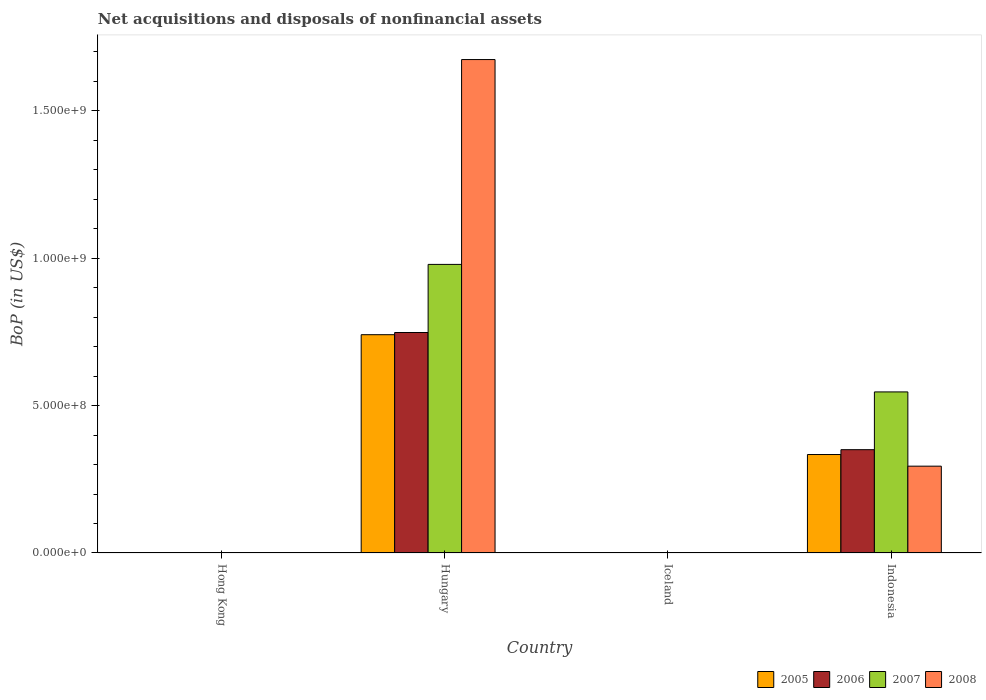Are the number of bars on each tick of the X-axis equal?
Offer a terse response. No. What is the label of the 1st group of bars from the left?
Your answer should be very brief. Hong Kong. What is the Balance of Payments in 2008 in Hungary?
Your answer should be very brief. 1.67e+09. Across all countries, what is the maximum Balance of Payments in 2007?
Offer a terse response. 9.79e+08. In which country was the Balance of Payments in 2006 maximum?
Your answer should be compact. Hungary. What is the total Balance of Payments in 2005 in the graph?
Make the answer very short. 1.07e+09. What is the difference between the Balance of Payments in 2007 in Hungary and that in Indonesia?
Your answer should be compact. 4.32e+08. What is the difference between the Balance of Payments in 2006 in Iceland and the Balance of Payments in 2005 in Indonesia?
Your response must be concise. -3.34e+08. What is the average Balance of Payments in 2005 per country?
Offer a terse response. 2.69e+08. What is the difference between the Balance of Payments of/in 2005 and Balance of Payments of/in 2008 in Indonesia?
Your answer should be compact. 3.95e+07. In how many countries, is the Balance of Payments in 2008 greater than 1000000000 US$?
Provide a succinct answer. 1. What is the ratio of the Balance of Payments in 2008 in Hungary to that in Indonesia?
Ensure brevity in your answer.  5.68. Is the Balance of Payments in 2008 in Hungary less than that in Indonesia?
Your response must be concise. No. What is the difference between the highest and the lowest Balance of Payments in 2005?
Make the answer very short. 7.40e+08. In how many countries, is the Balance of Payments in 2006 greater than the average Balance of Payments in 2006 taken over all countries?
Your answer should be compact. 2. How many bars are there?
Provide a short and direct response. 8. What is the difference between two consecutive major ticks on the Y-axis?
Ensure brevity in your answer.  5.00e+08. Where does the legend appear in the graph?
Make the answer very short. Bottom right. What is the title of the graph?
Your answer should be very brief. Net acquisitions and disposals of nonfinancial assets. What is the label or title of the Y-axis?
Ensure brevity in your answer.  BoP (in US$). What is the BoP (in US$) of 2005 in Hong Kong?
Your response must be concise. 0. What is the BoP (in US$) in 2008 in Hong Kong?
Offer a terse response. 0. What is the BoP (in US$) of 2005 in Hungary?
Offer a very short reply. 7.40e+08. What is the BoP (in US$) of 2006 in Hungary?
Your response must be concise. 7.48e+08. What is the BoP (in US$) of 2007 in Hungary?
Give a very brief answer. 9.79e+08. What is the BoP (in US$) of 2008 in Hungary?
Give a very brief answer. 1.67e+09. What is the BoP (in US$) of 2005 in Iceland?
Your response must be concise. 0. What is the BoP (in US$) of 2006 in Iceland?
Make the answer very short. 0. What is the BoP (in US$) of 2008 in Iceland?
Give a very brief answer. 0. What is the BoP (in US$) in 2005 in Indonesia?
Offer a very short reply. 3.34e+08. What is the BoP (in US$) in 2006 in Indonesia?
Keep it short and to the point. 3.50e+08. What is the BoP (in US$) in 2007 in Indonesia?
Provide a short and direct response. 5.46e+08. What is the BoP (in US$) of 2008 in Indonesia?
Keep it short and to the point. 2.94e+08. Across all countries, what is the maximum BoP (in US$) in 2005?
Make the answer very short. 7.40e+08. Across all countries, what is the maximum BoP (in US$) of 2006?
Provide a succinct answer. 7.48e+08. Across all countries, what is the maximum BoP (in US$) of 2007?
Offer a terse response. 9.79e+08. Across all countries, what is the maximum BoP (in US$) of 2008?
Provide a short and direct response. 1.67e+09. Across all countries, what is the minimum BoP (in US$) of 2007?
Keep it short and to the point. 0. What is the total BoP (in US$) in 2005 in the graph?
Give a very brief answer. 1.07e+09. What is the total BoP (in US$) in 2006 in the graph?
Provide a short and direct response. 1.10e+09. What is the total BoP (in US$) in 2007 in the graph?
Your answer should be compact. 1.52e+09. What is the total BoP (in US$) of 2008 in the graph?
Ensure brevity in your answer.  1.97e+09. What is the difference between the BoP (in US$) in 2005 in Hungary and that in Indonesia?
Keep it short and to the point. 4.06e+08. What is the difference between the BoP (in US$) in 2006 in Hungary and that in Indonesia?
Provide a succinct answer. 3.97e+08. What is the difference between the BoP (in US$) in 2007 in Hungary and that in Indonesia?
Make the answer very short. 4.32e+08. What is the difference between the BoP (in US$) of 2008 in Hungary and that in Indonesia?
Your answer should be very brief. 1.38e+09. What is the difference between the BoP (in US$) in 2005 in Hungary and the BoP (in US$) in 2006 in Indonesia?
Provide a succinct answer. 3.90e+08. What is the difference between the BoP (in US$) of 2005 in Hungary and the BoP (in US$) of 2007 in Indonesia?
Give a very brief answer. 1.94e+08. What is the difference between the BoP (in US$) in 2005 in Hungary and the BoP (in US$) in 2008 in Indonesia?
Offer a terse response. 4.46e+08. What is the difference between the BoP (in US$) of 2006 in Hungary and the BoP (in US$) of 2007 in Indonesia?
Keep it short and to the point. 2.01e+08. What is the difference between the BoP (in US$) in 2006 in Hungary and the BoP (in US$) in 2008 in Indonesia?
Make the answer very short. 4.53e+08. What is the difference between the BoP (in US$) of 2007 in Hungary and the BoP (in US$) of 2008 in Indonesia?
Ensure brevity in your answer.  6.84e+08. What is the average BoP (in US$) of 2005 per country?
Your answer should be very brief. 2.69e+08. What is the average BoP (in US$) in 2006 per country?
Provide a succinct answer. 2.75e+08. What is the average BoP (in US$) of 2007 per country?
Provide a short and direct response. 3.81e+08. What is the average BoP (in US$) of 2008 per country?
Your answer should be very brief. 4.92e+08. What is the difference between the BoP (in US$) in 2005 and BoP (in US$) in 2006 in Hungary?
Offer a terse response. -7.44e+06. What is the difference between the BoP (in US$) in 2005 and BoP (in US$) in 2007 in Hungary?
Offer a terse response. -2.38e+08. What is the difference between the BoP (in US$) of 2005 and BoP (in US$) of 2008 in Hungary?
Make the answer very short. -9.33e+08. What is the difference between the BoP (in US$) of 2006 and BoP (in US$) of 2007 in Hungary?
Ensure brevity in your answer.  -2.31e+08. What is the difference between the BoP (in US$) of 2006 and BoP (in US$) of 2008 in Hungary?
Your response must be concise. -9.26e+08. What is the difference between the BoP (in US$) of 2007 and BoP (in US$) of 2008 in Hungary?
Make the answer very short. -6.95e+08. What is the difference between the BoP (in US$) of 2005 and BoP (in US$) of 2006 in Indonesia?
Offer a very short reply. -1.64e+07. What is the difference between the BoP (in US$) in 2005 and BoP (in US$) in 2007 in Indonesia?
Your answer should be compact. -2.12e+08. What is the difference between the BoP (in US$) in 2005 and BoP (in US$) in 2008 in Indonesia?
Make the answer very short. 3.95e+07. What is the difference between the BoP (in US$) of 2006 and BoP (in US$) of 2007 in Indonesia?
Ensure brevity in your answer.  -1.96e+08. What is the difference between the BoP (in US$) of 2006 and BoP (in US$) of 2008 in Indonesia?
Offer a very short reply. 5.59e+07. What is the difference between the BoP (in US$) of 2007 and BoP (in US$) of 2008 in Indonesia?
Offer a terse response. 2.52e+08. What is the ratio of the BoP (in US$) of 2005 in Hungary to that in Indonesia?
Provide a short and direct response. 2.22. What is the ratio of the BoP (in US$) in 2006 in Hungary to that in Indonesia?
Provide a short and direct response. 2.13. What is the ratio of the BoP (in US$) of 2007 in Hungary to that in Indonesia?
Offer a very short reply. 1.79. What is the ratio of the BoP (in US$) in 2008 in Hungary to that in Indonesia?
Offer a terse response. 5.68. What is the difference between the highest and the lowest BoP (in US$) in 2005?
Your response must be concise. 7.40e+08. What is the difference between the highest and the lowest BoP (in US$) in 2006?
Make the answer very short. 7.48e+08. What is the difference between the highest and the lowest BoP (in US$) of 2007?
Offer a terse response. 9.79e+08. What is the difference between the highest and the lowest BoP (in US$) in 2008?
Offer a very short reply. 1.67e+09. 